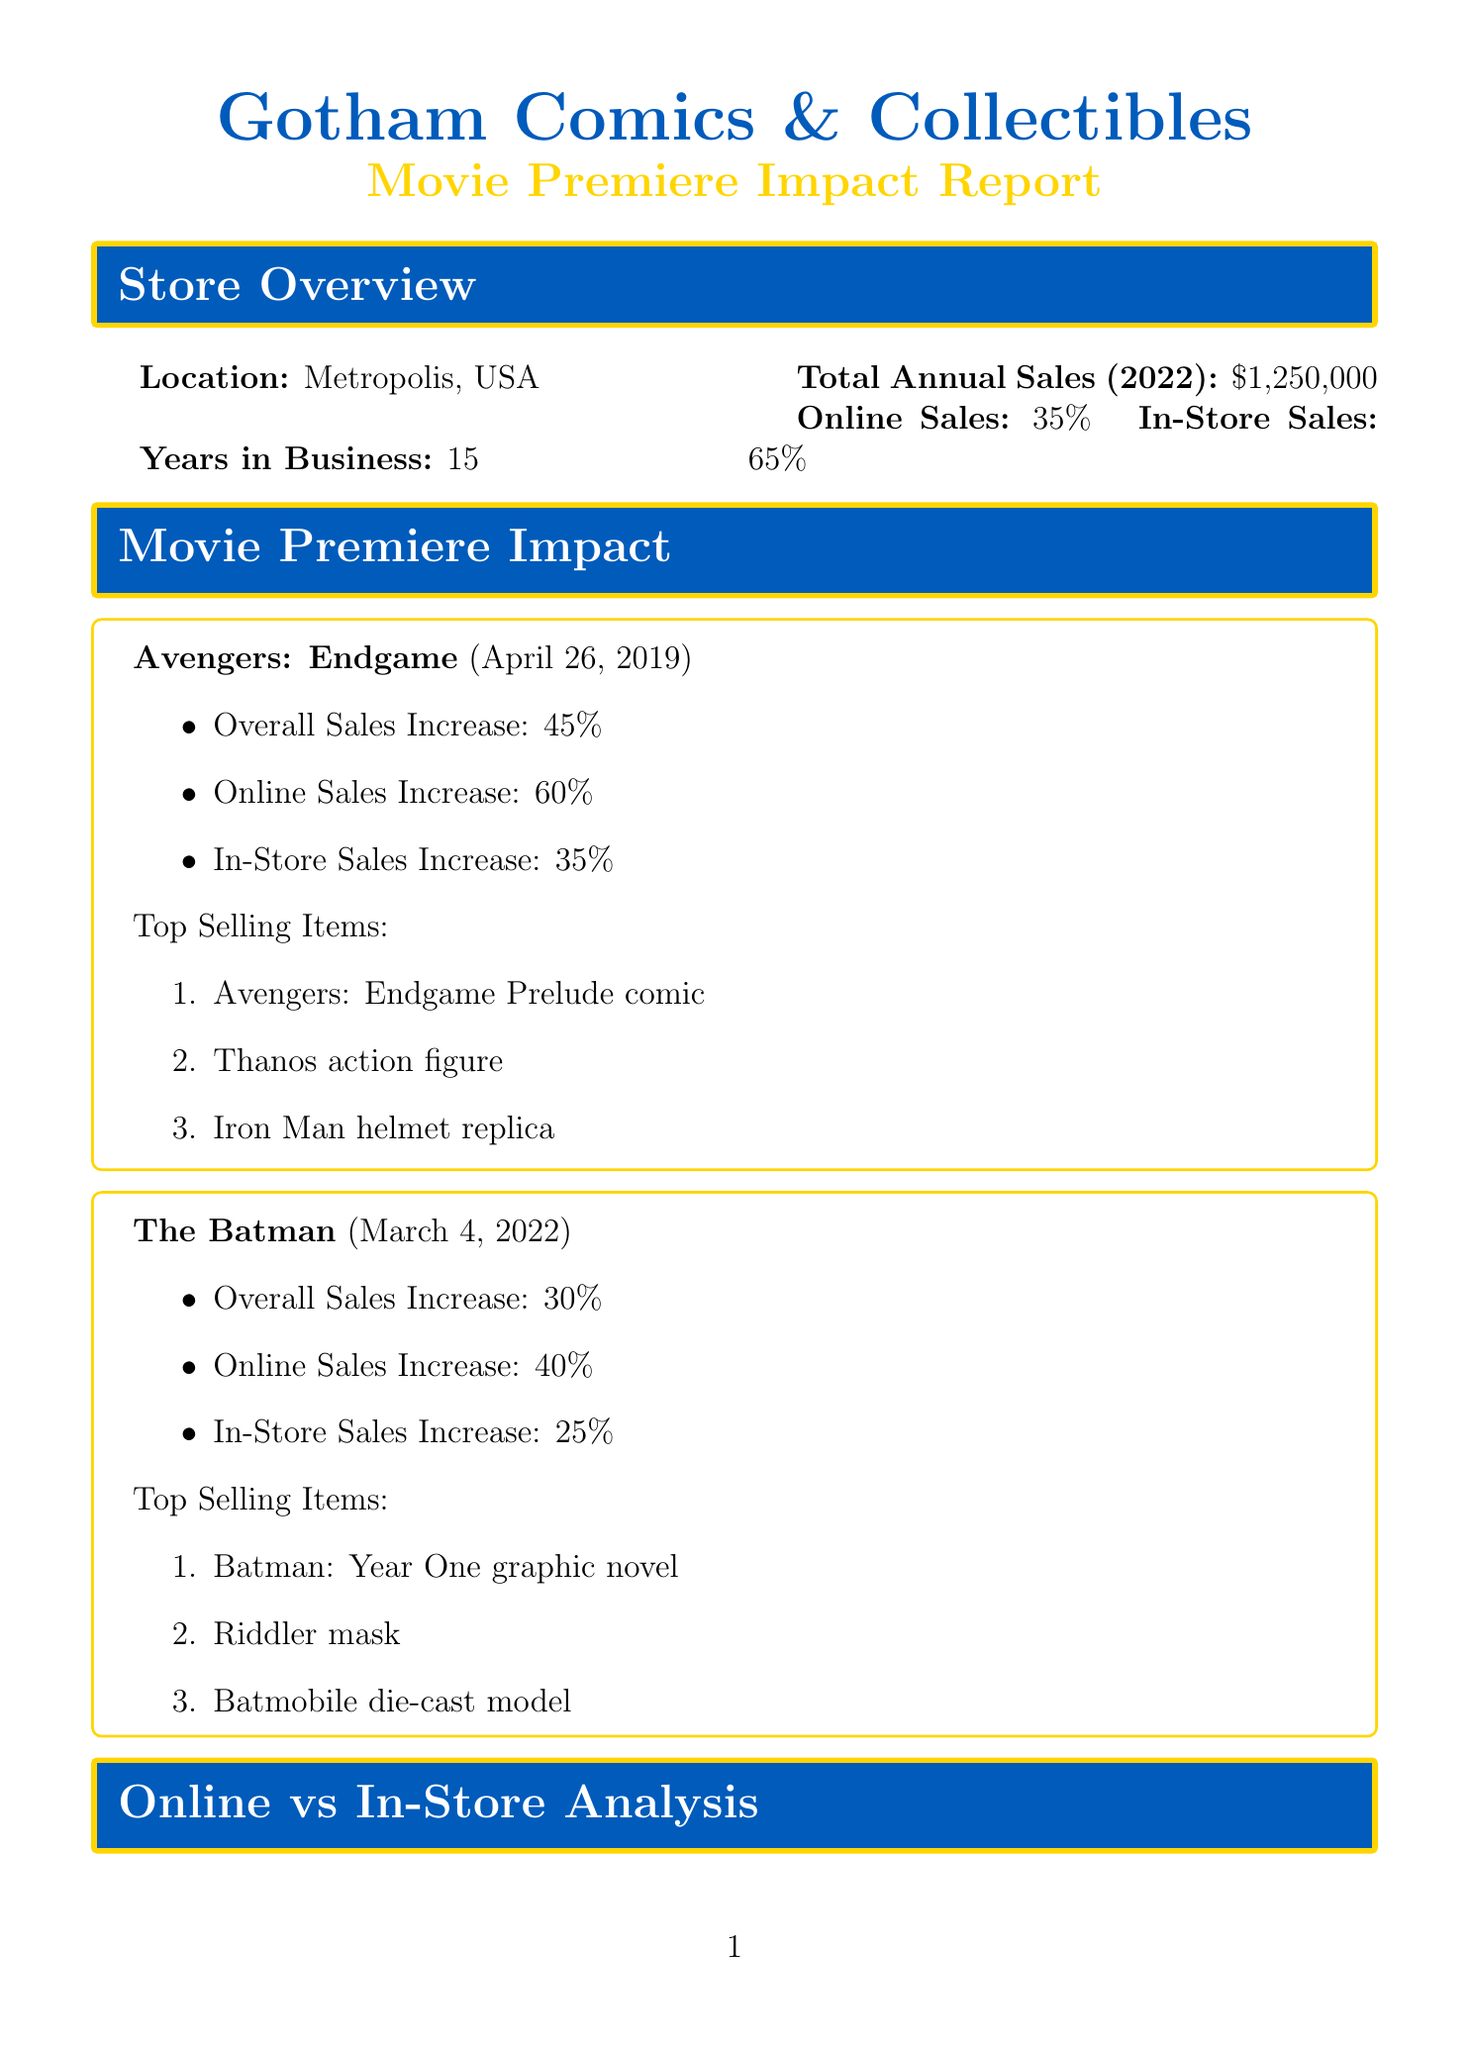what is the total annual sales for 2022? The total annual sales for 2022 is stated clearly in the document, which is $1,250,000.
Answer: $1,250,000 what percentage of sales are from online purchases? The document specifies that online sales comprise 35% of the total sales.
Answer: 35% what is the premiere date of The Batman? The premiere date for The Batman is provided as March 4, 2022.
Answer: March 4, 2022 which item increased online sales by 60% according to the movie premiere impact? The document lists Avengers: Endgame as having a 60% increase in online sales.
Answer: Avengers: Endgame what are the planned promotions for Guardians of the Galaxy Vol. 3? Planned promotions listed for Guardians of the Galaxy Vol. 3 include a plush toy giveaway, comic book sale, and pre-order bonus.
Answer: Rocket Raccoon plush toy giveaway, Guardians of the Galaxy comic book sale, Star-Lord helmet replica pre-order bonus what advantage does online shopping provide as mentioned in the analysis? The document lists several advantages, including 24/7 availability as a benefit of online shopping.
Answer: 24/7 availability which movie is anticipated to have a very high sales impact? The document indicates that Spider-Man: Across the Spider-Verse is expected to have a very high sales impact.
Answer: Spider-Man: Across the Spider-Verse what is one of the movie tie-in strategies mentioned? The document includes several movie tie-in strategies, one being themed movie nights.
Answer: Themed movie nights which trend relates to offering digital codes with physical purchases? The trend regarding digital codes is labeled as "Digital comics integration" in the industry trends section.
Answer: Digital comics integration 